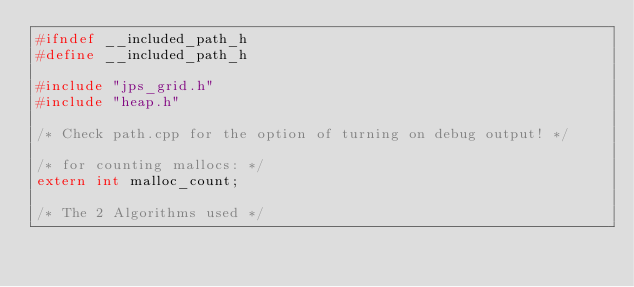Convert code to text. <code><loc_0><loc_0><loc_500><loc_500><_C_>#ifndef __included_path_h
#define __included_path_h

#include "jps_grid.h"
#include "heap.h"

/* Check path.cpp for the option of turning on debug output! */

/* for counting mallocs: */
extern int malloc_count;

/* The 2 Algorithms used */</code> 